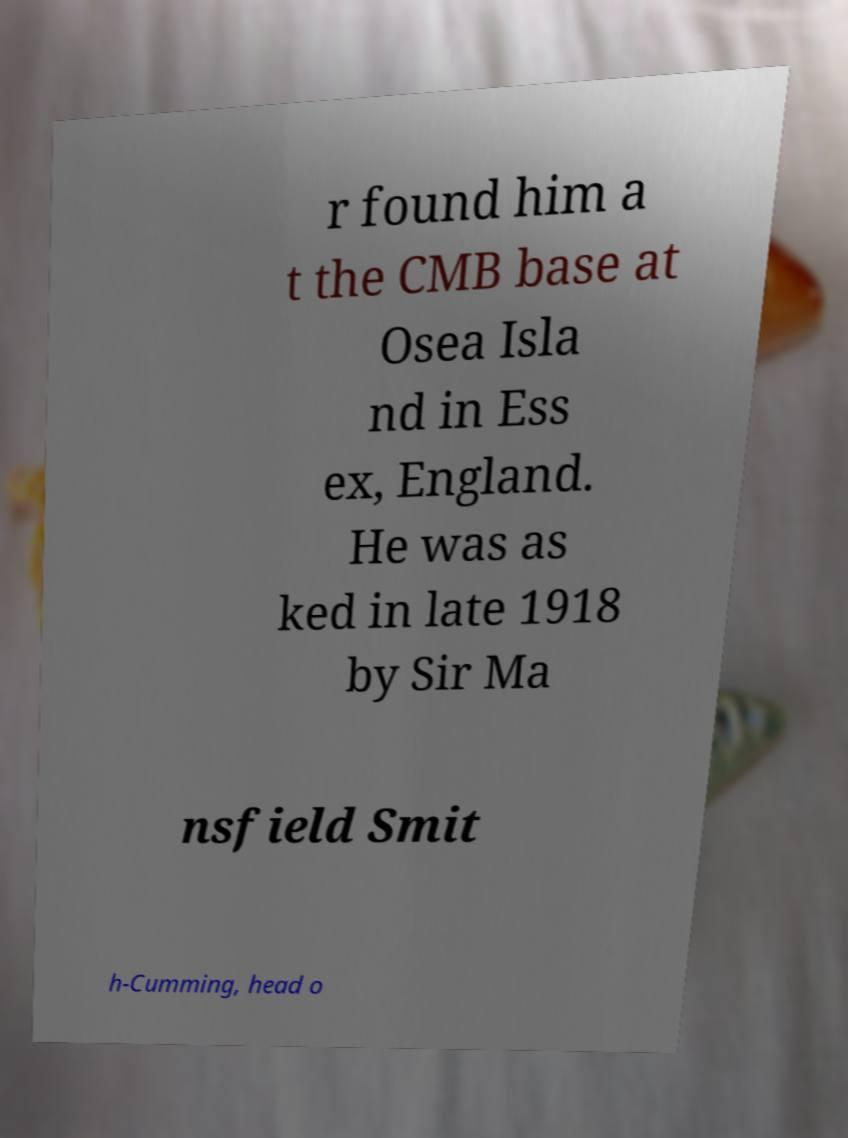Could you extract and type out the text from this image? r found him a t the CMB base at Osea Isla nd in Ess ex, England. He was as ked in late 1918 by Sir Ma nsfield Smit h-Cumming, head o 